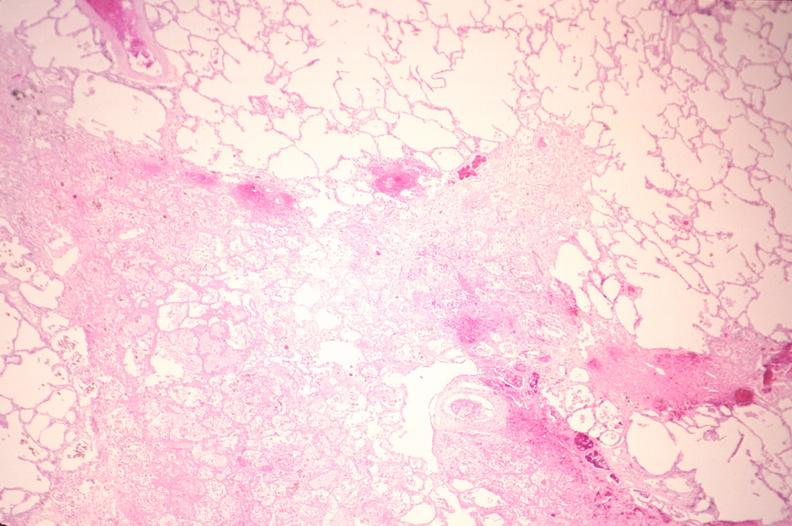what is present?
Answer the question using a single word or phrase. Respiratory 